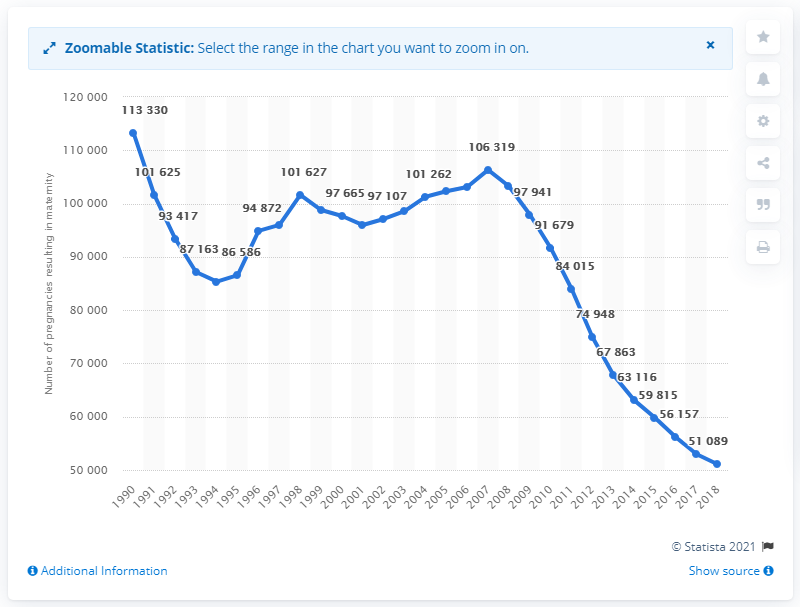Highlight a few significant elements in this photo. In 2018, there were 51,089 teenage conceptions in England and Wales. There were 106,319 teenage pregnancies in 2007. The number of teenage conceptions has been declining since 2007. 